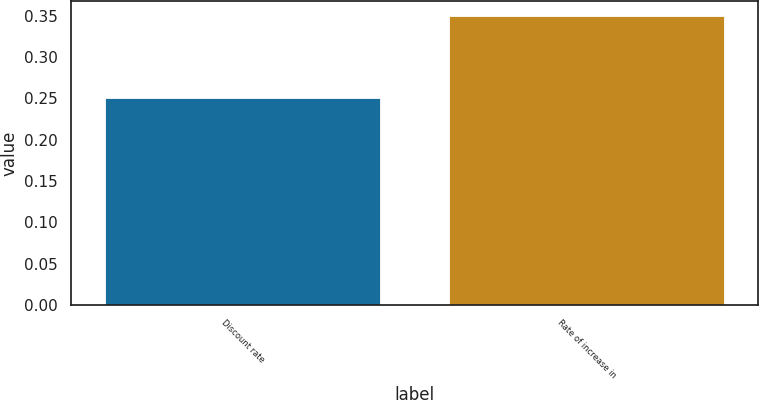Convert chart. <chart><loc_0><loc_0><loc_500><loc_500><bar_chart><fcel>Discount rate<fcel>Rate of increase in<nl><fcel>0.25<fcel>0.35<nl></chart> 